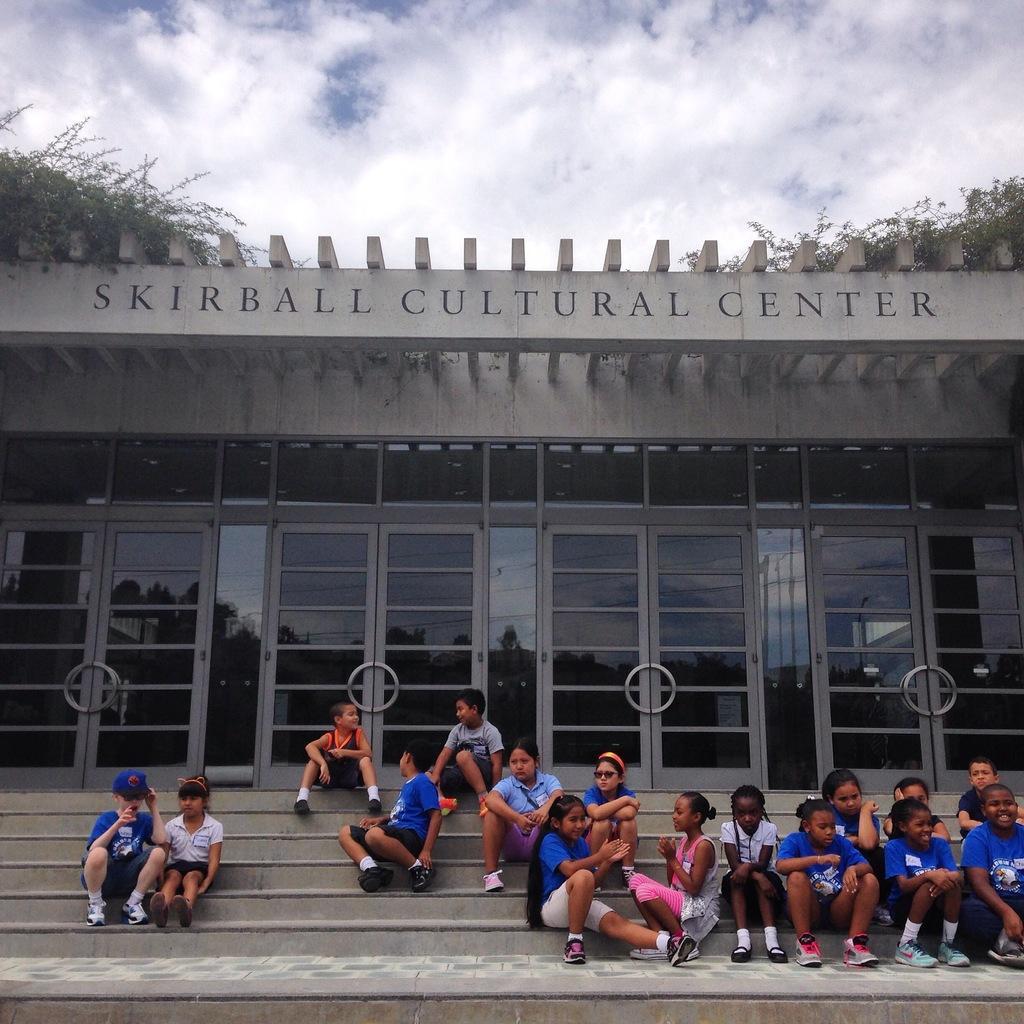How would you summarize this image in a sentence or two? In this image we can see children sitting on the stairs, we can see glass doors, above that we can see some written text, near that we can see the plants, at the top we can see the sky with clouds. 